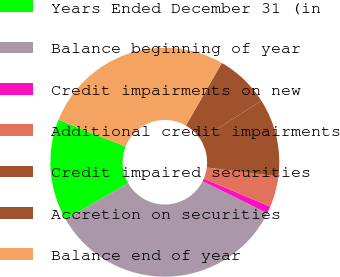Convert chart to OTSL. <chart><loc_0><loc_0><loc_500><loc_500><pie_chart><fcel>Years Ended December 31 (in<fcel>Balance beginning of year<fcel>Credit impairments on new<fcel>Additional credit impairments<fcel>Credit impaired securities<fcel>Accretion on securities<fcel>Balance end of year<nl><fcel>14.34%<fcel>34.33%<fcel>1.02%<fcel>4.35%<fcel>11.01%<fcel>7.68%<fcel>27.25%<nl></chart> 